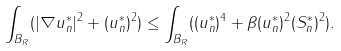<formula> <loc_0><loc_0><loc_500><loc_500>\int _ { B _ { R } } ( | \nabla u _ { n } ^ { * } | ^ { 2 } + ( u _ { n } ^ { * } ) ^ { 2 } ) \leq \int _ { B _ { R } } ( ( u _ { n } ^ { * } ) ^ { 4 } + \beta ( u _ { n } ^ { * } ) ^ { 2 } ( S _ { n } ^ { * } ) ^ { 2 } ) .</formula> 